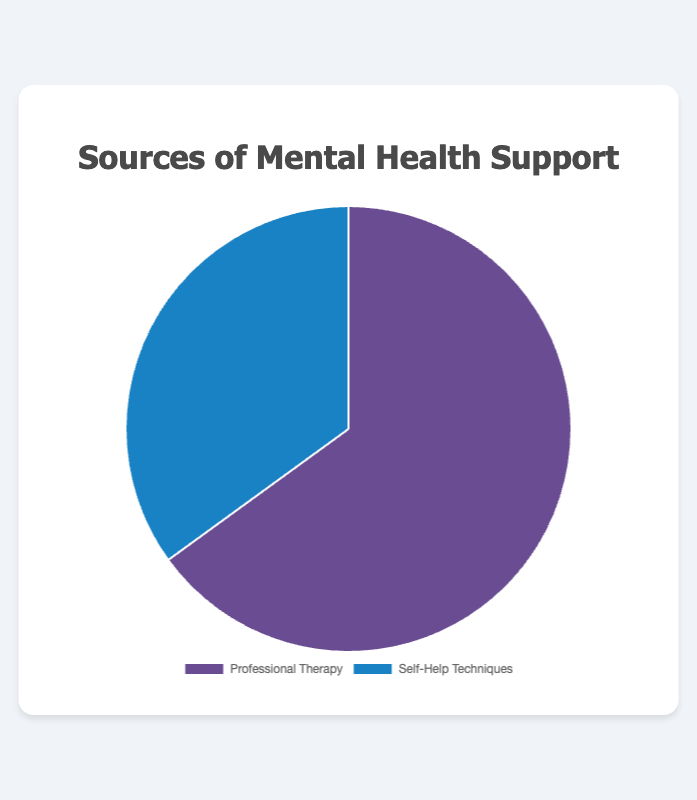What percentage of mental health support reported in the chart comes from professional therapy? The chart shows that professional therapy accounts for 65% of the mental health support sources.
Answer: 65% What is the percentage difference between professional therapy and self-help techniques? To find the percentage difference, subtract the smaller percentage from the larger one: 65% (professional therapy) - 35% (self-help techniques) = 30%.
Answer: 30% What is the combined percentage of mental health support from both sources? Adding the percentages for both sources: 65% (professional therapy) + 35% (self-help techniques) = 100%.
Answer: 100% What is the ratio of professional therapy to self-help techniques as a source of mental health support? The ratio is found by dividing the percentage of professional therapy by the percentage of self-help techniques: 65 / 35. Simplifying the ratio: 65/35 = 13/7.
Answer: 13:7 Considering the visual representation, which segment is larger in size? The larger segment in the pie chart is the one representing professional therapy, which is 65%.
Answer: Professional therapy By how many percentage points does professional therapy exceed self-help techniques in the chart? The exceedance is 65% (professional therapy) - 35% (self-help techniques) = 30 percentage points.
Answer: 30 What is the color representing self-help techniques in the pie chart? The self-help techniques are represented by the blue color slice in the pie chart.
Answer: Blue How might the visual size difference between the segments help in understanding the preference for different mental health support sources? The larger segment visually indicates a greater preference or usage, making it quicker to understand at a glance that professional therapy is more commonly used than self-help techniques.
Answer: The larger segment highlights greater usage of professional therapy If someone were to rely equally on both sources, what percentage would each need to be? Relying equally on both sources would mean each source should account for 50% of the mental health support.
Answer: 50% 